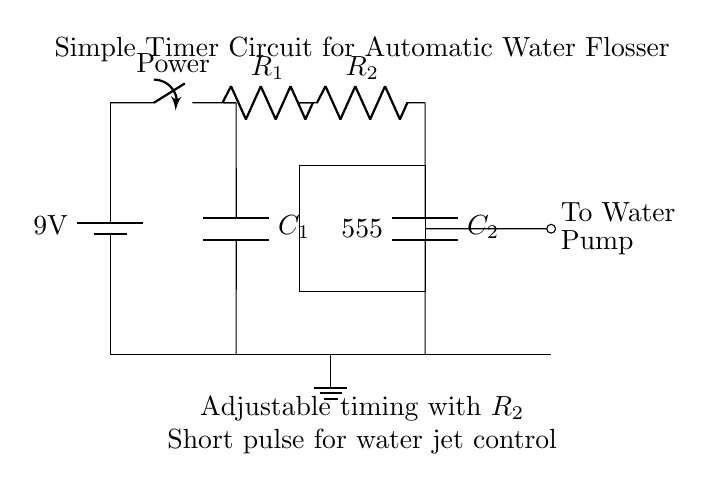What is the voltage of this circuit? The circuit is powered by a 9V battery, which means the potential difference across the circuit is 9 volts.
Answer: 9 volts What type of circuit is this? This is a timer circuit specifically designed for an automatic water flosser, utilizing a 555 timer IC to control timing for the water pump.
Answer: Timer circuit How many resistors are present in the circuit? There are two resistors labeled R1 and R2 in the circuit.
Answer: Two What is the purpose of capacitor C1? Capacitor C1 is used to store electrical energy and work alongside the timer IC to determine the timing intervals for the water flosser operation by charging and discharging.
Answer: Timing control What component controls the water pump operation? The output from the 555 timer IC drives the water pump, allowing it to operate when the timing conditions are met.
Answer: 555 timer IC What is adjustable in this circuit? The timing interval is adjustable by changing the value of resistor R2, which alters the charge time for the capacitor connected to the timer IC.
Answer: Timing interval 